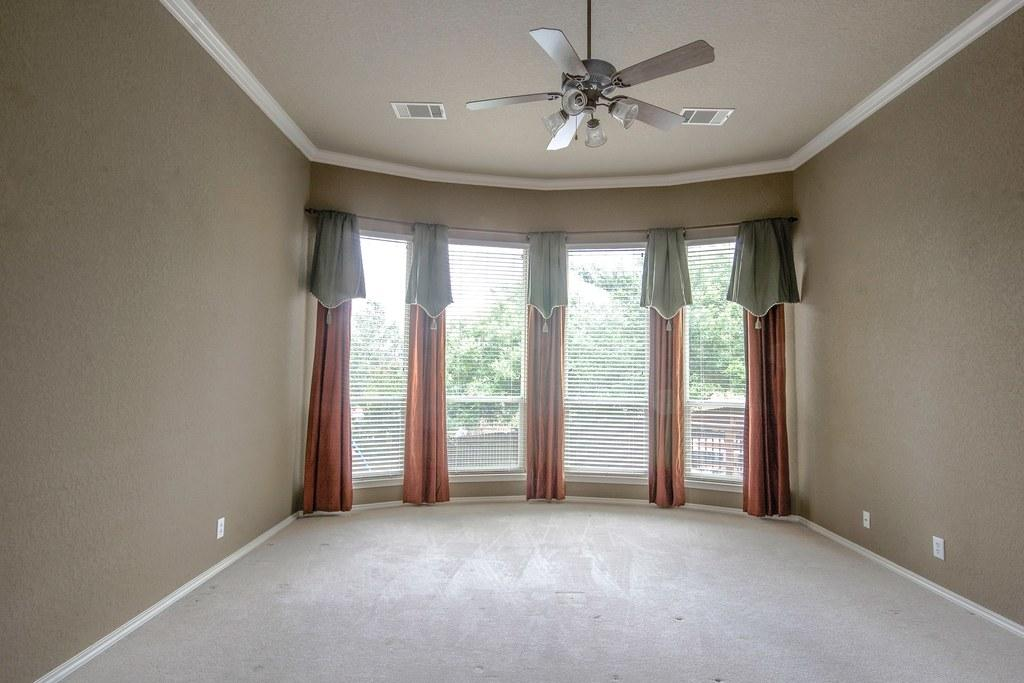What is the main object in the image? There is a ceiling fan in the image. What can be seen in the background of the image? There is a glass door in the background of the image. What type of window treatment is associated with the glass door? There are curtains associated with the glass door. What is visible through the glass door? Trees are visible through the glass door. What type of goat can be seen standing on the ceiling fan in the image? There is no goat present in the image, and the ceiling fan is not designed to support any animals. 